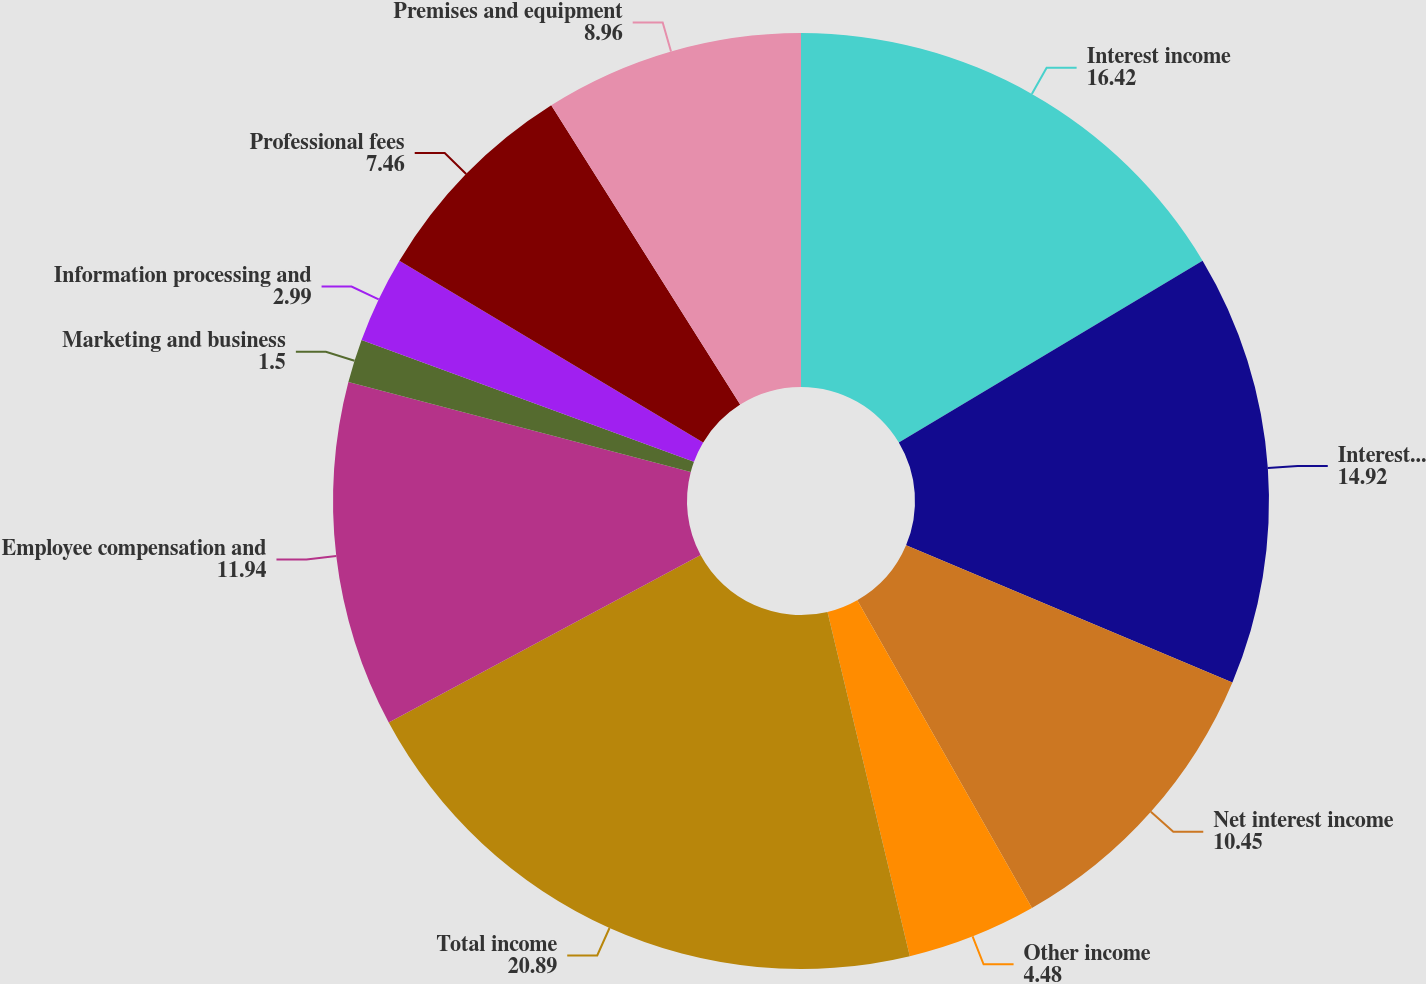Convert chart to OTSL. <chart><loc_0><loc_0><loc_500><loc_500><pie_chart><fcel>Interest income<fcel>Interest expense<fcel>Net interest income<fcel>Other income<fcel>Total income<fcel>Employee compensation and<fcel>Marketing and business<fcel>Information processing and<fcel>Professional fees<fcel>Premises and equipment<nl><fcel>16.42%<fcel>14.92%<fcel>10.45%<fcel>4.48%<fcel>20.89%<fcel>11.94%<fcel>1.5%<fcel>2.99%<fcel>7.46%<fcel>8.96%<nl></chart> 